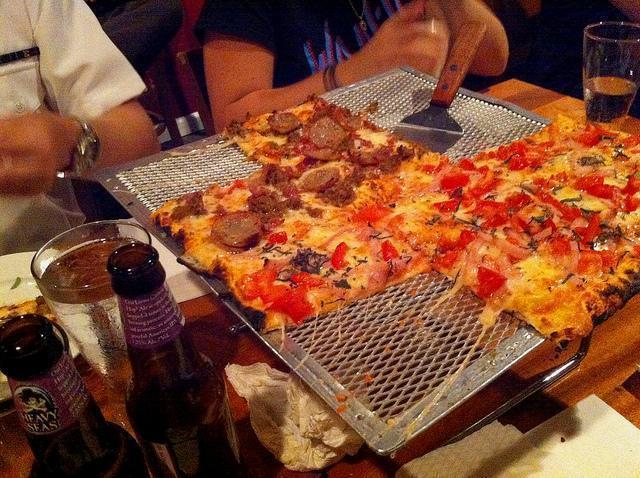What is the topping shown?
Select the accurate answer and provide explanation: 'Answer: answer
Rationale: rationale.'
Options: Mustard, pepperoni, sausage, bell pepper. Answer: bell pepper.
Rationale: This is a common pizza topping. the pepper shown is of the red colored variety. 